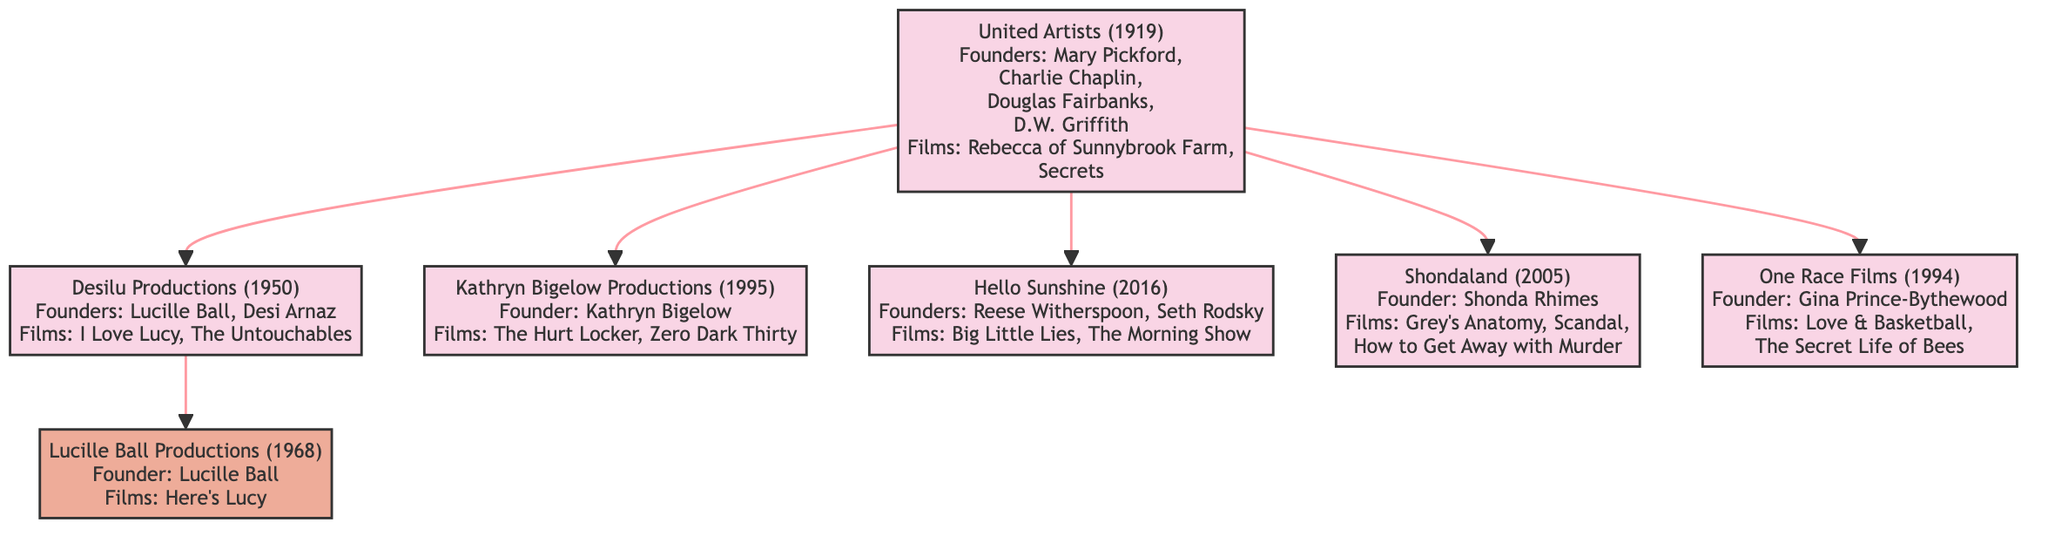What company was founded first in this tree? The diagram shows United Artists as the top ancestor, which was founded in 1919, making it the oldest company in this family tree.
Answer: United Artists How many notable films are associated with Desilu Productions? According to the diagram, Desilu Productions has two notable films listed: "I Love Lucy" and "The Untouchables." Therefore, the count is two.
Answer: 2 Who founded Hello Sunshine? The diagram indicates that Hello Sunshine was founded by Reese Witherspoon and Seth Rodsky, thus naming the primary founder as Reese Witherspoon since she is a well-known actress and a face of the company.
Answer: Reese Witherspoon What is the founding year of One Race Films? By examining the diagram, One Race Films is marked with the founding year of 1994, which directly answers the question regarding when it was established.
Answer: 1994 Which production company directly influenced Lucille Ball Productions? The diagram illustrates that Desilu Productions, founded by Lucille Ball and Desi Arnaz, is directly connected to Lucille Ball Productions, indicating that Desilu influenced Lucille Ball Productions.
Answer: Desilu Productions How many production companies are linked as branches to United Artists? In the diagram, there are five branches that extend from United Artists, specifically Desilu Productions, Kathryn Bigelow Productions, Hello Sunshine, Shondaland, and One Race Films. This totals five distinct companies.
Answer: 5 What notable film is associated with Kathryn Bigelow Productions? Based on the diagram, one of the notable films linked to Kathryn Bigelow Productions is "The Hurt Locker," which is listed under this company.
Answer: The Hurt Locker Which founder is credited with establishing Shondaland? The diagram credits Shonda Rhimes as the founder of Shondaland, as shown in the information on this particular production company.
Answer: Shonda Rhimes What relationship does Lucille Ball Productions have with Desilu Productions? The diagram specifies that Lucille Ball Productions is directly influenced by Desilu Productions, suggesting a mentorship or inspiration relationship originating from Desilu, which was co-founded by Lucille Ball herself.
Answer: Influenced by Desilu Productions 